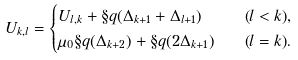<formula> <loc_0><loc_0><loc_500><loc_500>U _ { k , l } & = \begin{cases} U _ { l , k } + \S q ( \Delta _ { k + 1 } + \Delta _ { l + 1 } ) & \text {\quad($l<k$),} \\ \mu _ { 0 } \S q ( \Delta _ { k + 2 } ) + \S q ( 2 \Delta _ { k + 1 } ) & \text {\quad($l=k$).} \end{cases}</formula> 